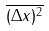<formula> <loc_0><loc_0><loc_500><loc_500>\overline { ( \Delta x ) ^ { 2 } }</formula> 